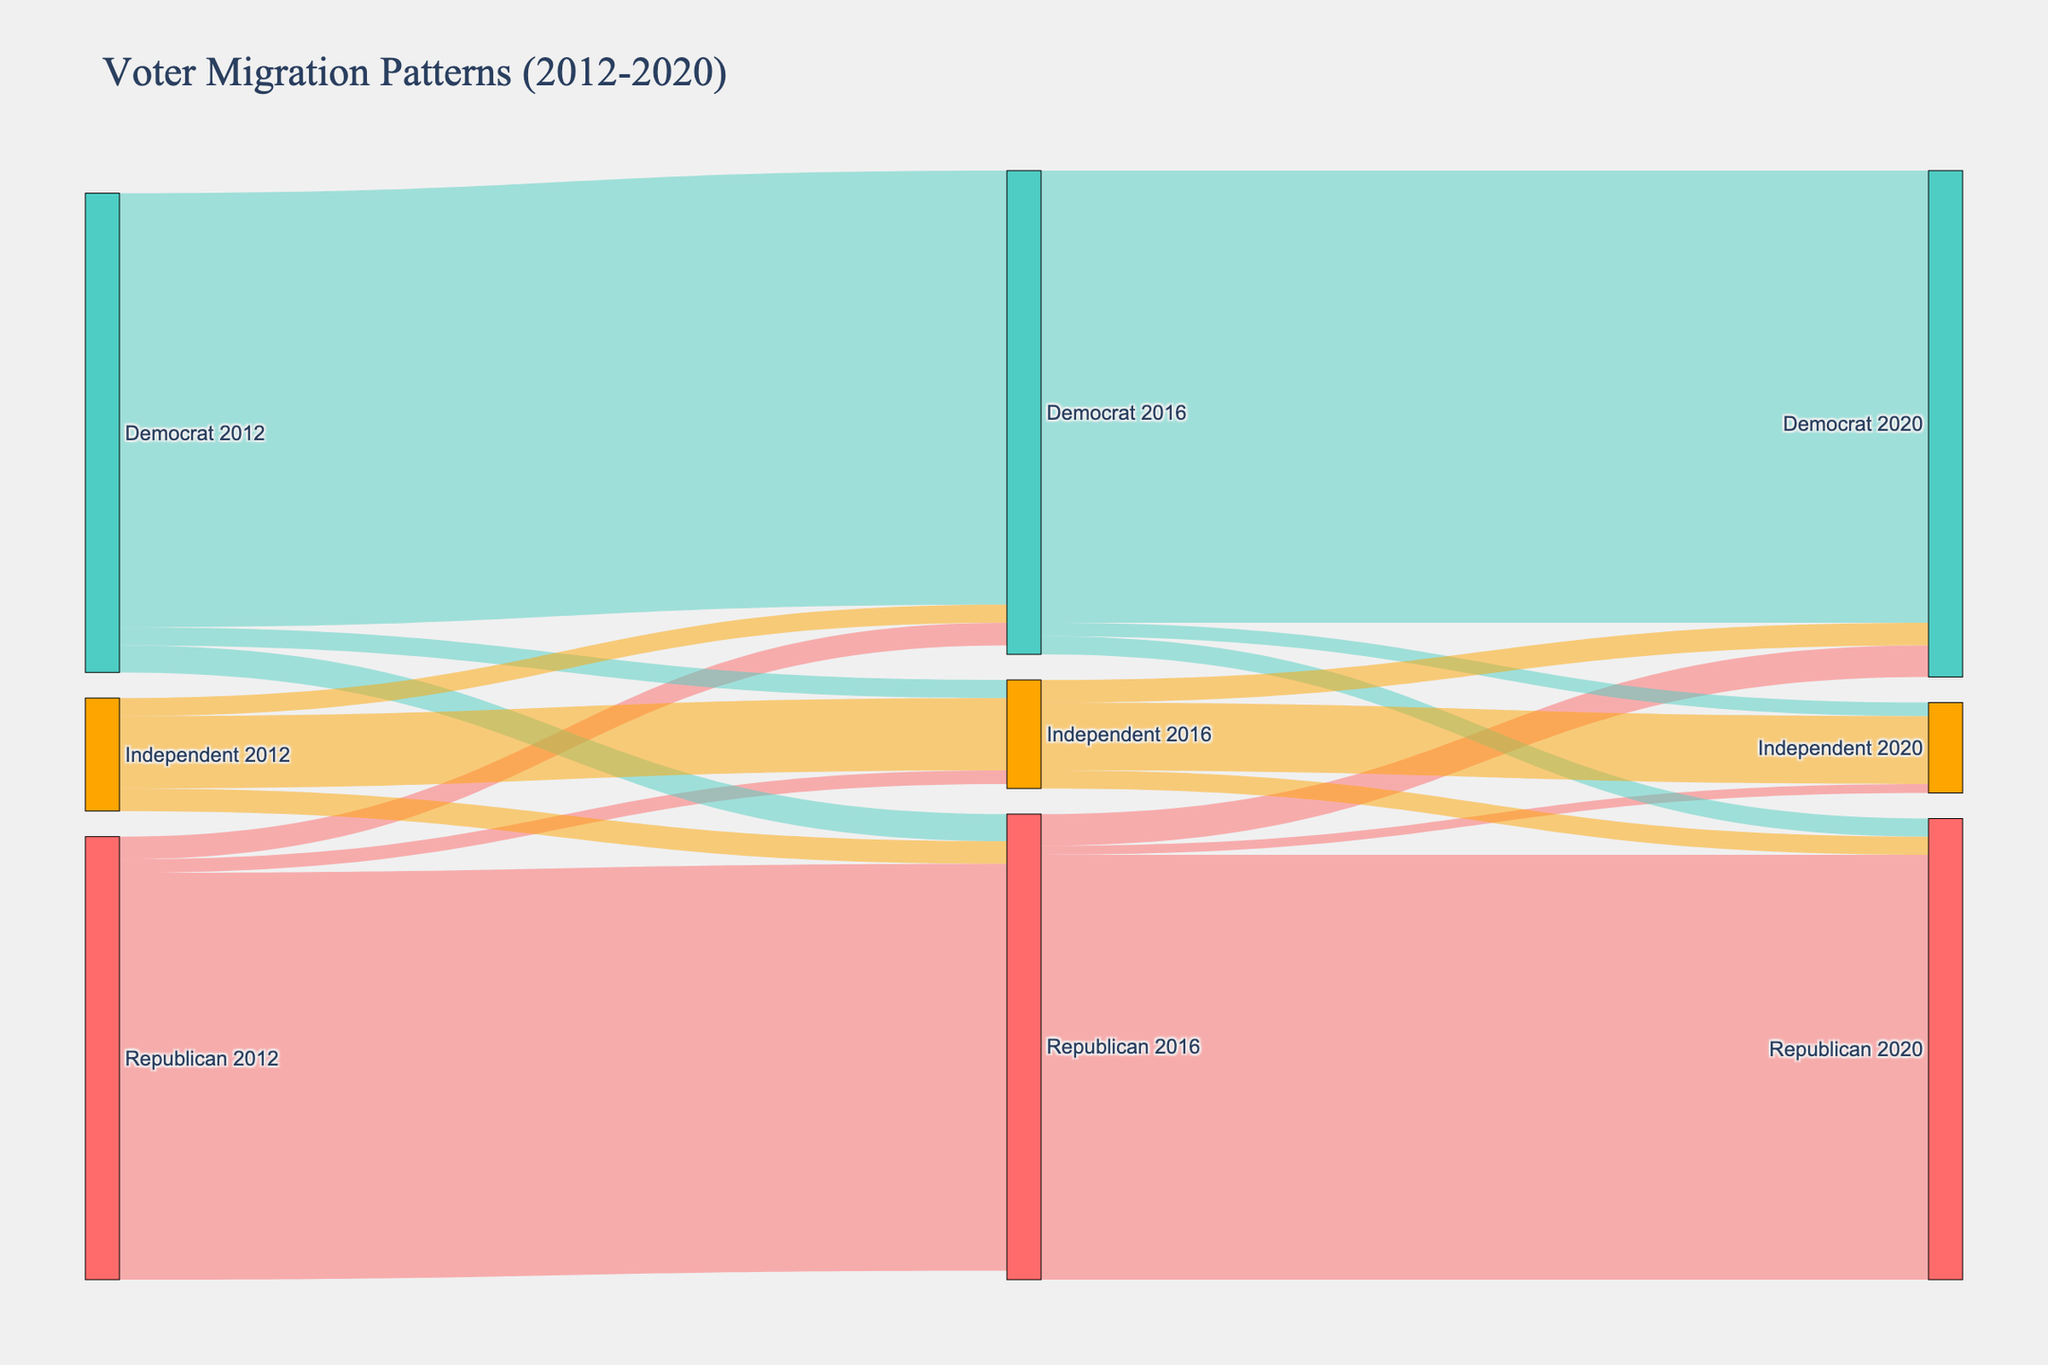What is the title of the Sankey Diagram? The title is located at the top of the figure, providing a brief summary of what the diagram represents. In this case, the title given is "Voter Migration Patterns (2012-2020)."
Answer: Voter Migration Patterns (2012-2020) How many categories of parties are represented in the dataset? By looking at the diagram, you can see three categories of parties represented: Republican, Democrat, and Independent. They are depicted with different colors.
Answer: 3 What's the total number of voters who shifted from Republican in 2012 to Democrat in 2016? By examining the flows from Republican 2012 to Democrat 2016, the value (width of the flow) represents the number of voters migrating. The value at this flow is shown as 2,500,000.
Answer: 2,500,000 Which party saw the highest voter retention from 2016 to 2020? To determine this, we need to compare the flows that loop back to the same party from 2016 to 2020. The highest value of retained voters would signify the highest retention. Democrat to Democrat in 2016-2020 shows a retention of 50,000,000 voters.
Answer: Democrat What is the sum of voters who moved to the Republican party in 2020 from other parties in 2016? Calculate the sum of all flows pointing to Republican 2020 from different parties in 2016. This includes voters from Republican 2016 (47,000,000), Democrat 2016 (2,000,000), and Independent 2016 (2,000,000). The total is 47,000,000 + 2,000,000 + 2,000,000 = 51,000,000.
Answer: 51,000,000 How many voters stayed with the Independent party from 2012 to 2016 and then again from 2016 to 2020? Identify the value flows within the Independent category for the two consecutive periods. For 2012 to 2016, it's 8,000,000, and for 2016 to 2020, it's 7,500,000. The combined stays are directly added without further steps: 8,000,000 + 7,500,000 = 15,500,000.
Answer: 15,500,000 Comparing the voter migration from Democrat to Independent between election cycles 2012 to 2016 and 2016 to 2020, which cycle saw more movers? Check the flows for Democrat to Independent for the specified periods. From 2012 to 2016 it is 2,000,000, and from 2016 to 2020 it is 1,500,000. Compare these values; more movers occurred from 2012 to 2016.
Answer: 2012 to 2016 How many voters switched from the Independent party to Democrat between 2016 and 2020? Look at the value of the flow from Independent 2016 to Democrat 2020 within the diagram. It shows a flow of 2,500,000 voters.
Answer: 2,500,000 Which flow indicates the smallest number of voters switching between parties? To find the smallest flow, observe all flows in the diagram. The smallest observed flow is from Republican 2016 to Independent 2020 with a value of 1,000,000.
Answer: Republican 2016 to Independent 2020 